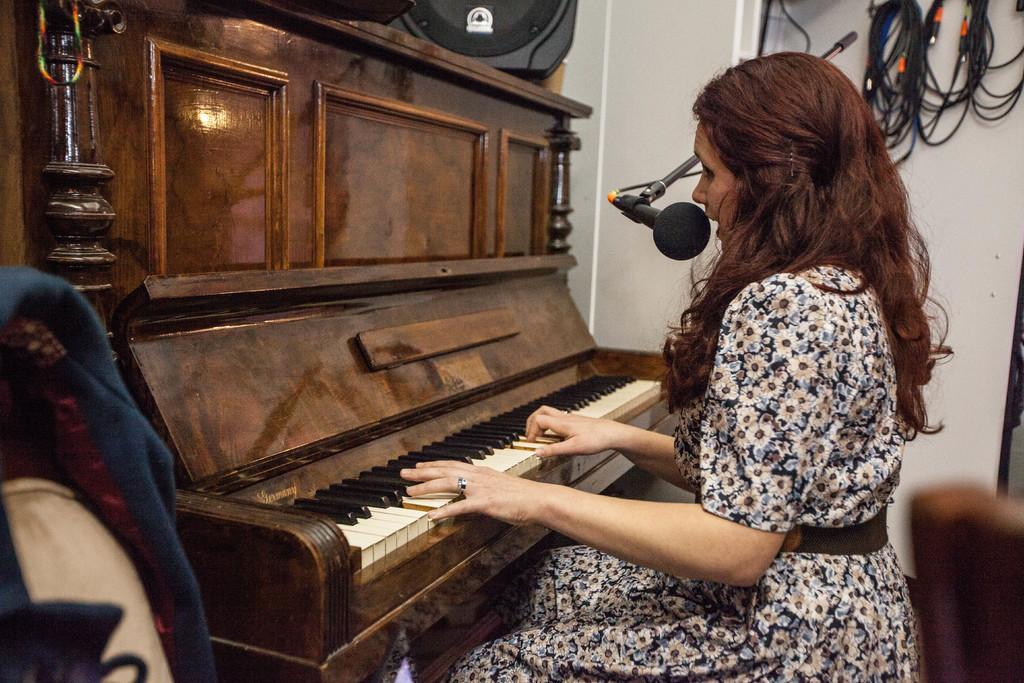Who is present in the room in the image? There is a woman in the room. What is the woman doing in the image? The woman is sitting and playing the piano. What can be seen behind the woman? There is a wall behind the woman. What is attached to the wall? Wires are hanging on the wall. What type of furniture is present in the room? There are chairs with a cloth hanging on them. What type of hole can be seen in the image? There is no hole present in the image. Is the woman in the image a prisoner? There is no indication in the image that the woman is a prisoner. 